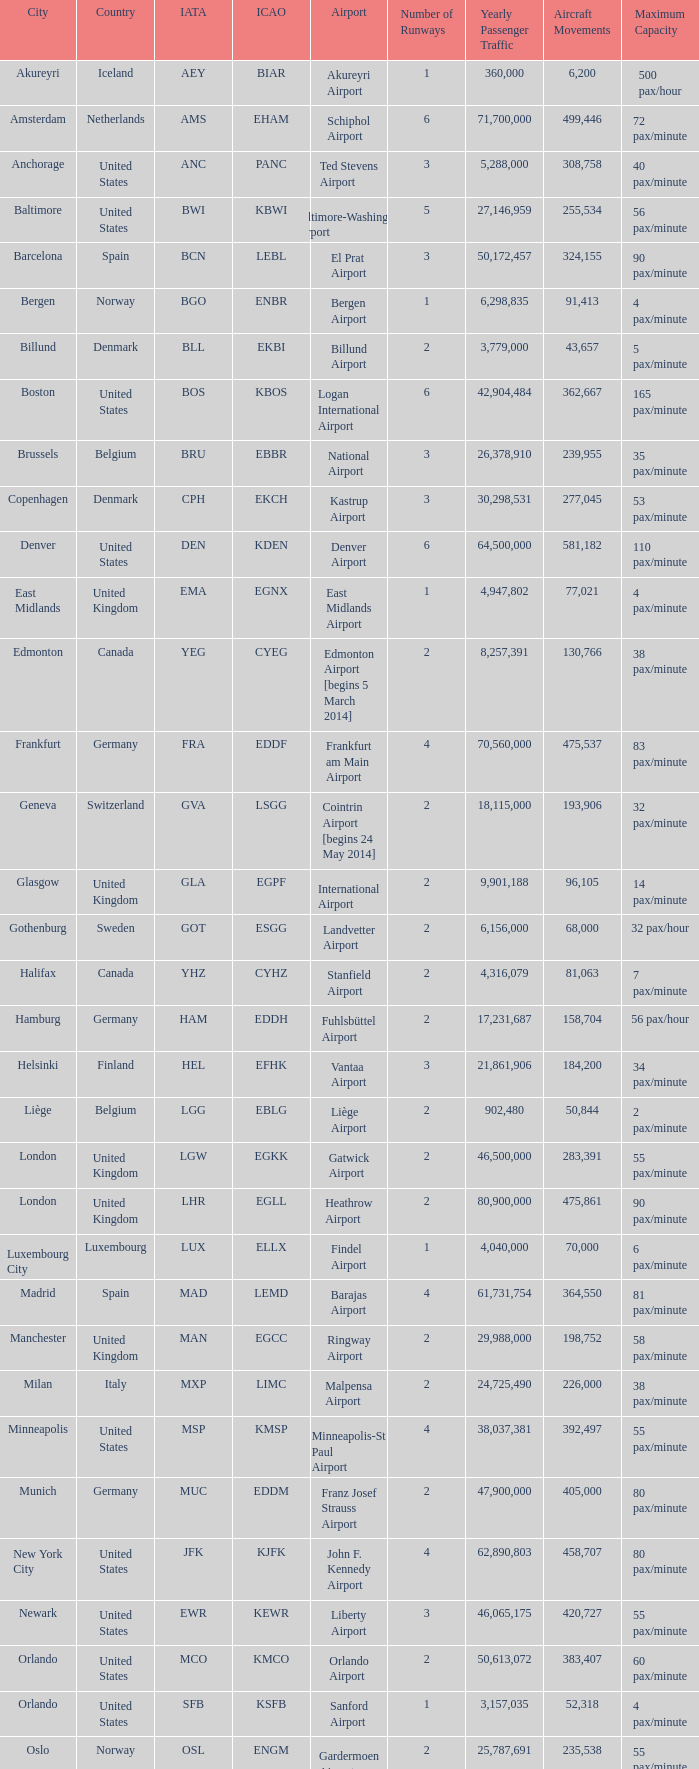Would you be able to parse every entry in this table? {'header': ['City', 'Country', 'IATA', 'ICAO', 'Airport', 'Number of Runways', 'Yearly Passenger Traffic', 'Aircraft Movements', 'Maximum Capacity'], 'rows': [['Akureyri', 'Iceland', 'AEY', 'BIAR', 'Akureyri Airport', '1', '360,000', '6,200', '500 pax/hour'], ['Amsterdam', 'Netherlands', 'AMS', 'EHAM', 'Schiphol Airport', '6', '71,700,000', '499,446', '72 pax/minute'], ['Anchorage', 'United States', 'ANC', 'PANC', 'Ted Stevens Airport', '3', '5,288,000', '308,758', '40 pax/minute'], ['Baltimore', 'United States', 'BWI', 'KBWI', 'Baltimore-Washington Airport', '5', '27,146,959', '255,534', '56 pax/minute'], ['Barcelona', 'Spain', 'BCN', 'LEBL', 'El Prat Airport', '3', '50,172,457', '324,155', '90 pax/minute'], ['Bergen', 'Norway', 'BGO', 'ENBR', 'Bergen Airport', '1', '6,298,835', '91,413', '4 pax/minute'], ['Billund', 'Denmark', 'BLL', 'EKBI', 'Billund Airport', '2', '3,779,000', '43,657', '5 pax/minute'], ['Boston', 'United States', 'BOS', 'KBOS', 'Logan International Airport', '6', '42,904,484', '362,667', '165 pax/minute'], ['Brussels', 'Belgium', 'BRU', 'EBBR', 'National Airport', '3', '26,378,910', '239,955', '35 pax/minute'], ['Copenhagen', 'Denmark', 'CPH', 'EKCH', 'Kastrup Airport', '3', '30,298,531', '277,045', '53 pax/minute'], ['Denver', 'United States', 'DEN', 'KDEN', 'Denver Airport', '6', '64,500,000', '581,182', '110 pax/minute'], ['East Midlands', 'United Kingdom', 'EMA', 'EGNX', 'East Midlands Airport', '1', '4,947,802', '77,021', '4 pax/minute'], ['Edmonton', 'Canada', 'YEG', 'CYEG', 'Edmonton Airport [begins 5 March 2014]', '2', '8,257,391', '130,766', '38 pax/minute'], ['Frankfurt', 'Germany', 'FRA', 'EDDF', 'Frankfurt am Main Airport', '4', '70,560,000', '475,537', '83 pax/minute'], ['Geneva', 'Switzerland', 'GVA', 'LSGG', 'Cointrin Airport [begins 24 May 2014]', '2', '18,115,000', '193,906', '32 pax/minute'], ['Glasgow', 'United Kingdom', 'GLA', 'EGPF', 'International Airport', '2', '9,901,188', '96,105', '14 pax/minute'], ['Gothenburg', 'Sweden', 'GOT', 'ESGG', 'Landvetter Airport', '2', '6,156,000', '68,000', '32 pax/hour'], ['Halifax', 'Canada', 'YHZ', 'CYHZ', 'Stanfield Airport', '2', '4,316,079', '81,063', '7 pax/minute'], ['Hamburg', 'Germany', 'HAM', 'EDDH', 'Fuhlsbüttel Airport', '2', '17,231,687', '158,704', '56 pax/hour'], ['Helsinki', 'Finland', 'HEL', 'EFHK', 'Vantaa Airport', '3', '21,861,906', '184,200', '34 pax/minute'], ['Liège', 'Belgium', 'LGG', 'EBLG', 'Liège Airport', '2', '902,480', '50,844', '2 pax/minute'], ['London', 'United Kingdom', 'LGW', 'EGKK', 'Gatwick Airport', '2', '46,500,000', '283,391', '55 pax/minute'], ['London', 'United Kingdom', 'LHR', 'EGLL', 'Heathrow Airport', '2', '80,900,000', '475,861', '90 pax/minute'], ['Luxembourg City', 'Luxembourg', 'LUX', 'ELLX', 'Findel Airport', '1', '4,040,000', '70,000', '6 pax/minute'], ['Madrid', 'Spain', 'MAD', 'LEMD', 'Barajas Airport', '4', '61,731,754', '364,550', '81 pax/minute'], ['Manchester', 'United Kingdom', 'MAN', 'EGCC', 'Ringway Airport', '2', '29,988,000', '198,752', '58 pax/minute'], ['Milan', 'Italy', 'MXP', 'LIMC', 'Malpensa Airport', '2', '24,725,490', '226,000', '38 pax/minute'], ['Minneapolis', 'United States', 'MSP', 'KMSP', 'Minneapolis-St Paul Airport', '4', '38,037,381', '392,497', '55 pax/minute'], ['Munich', 'Germany', 'MUC', 'EDDM', 'Franz Josef Strauss Airport', '2', '47,900,000', '405,000', '80 pax/minute'], ['New York City', 'United States', 'JFK', 'KJFK', 'John F. Kennedy Airport', '4', '62,890,803', '458,707', '80 pax/minute'], ['Newark', 'United States', 'EWR', 'KEWR', 'Liberty Airport', '3', '46,065,175', '420,727', '55 pax/minute'], ['Orlando', 'United States', 'MCO', 'KMCO', 'Orlando Airport', '2', '50,613,072', '383,407', '60 pax/minute'], ['Orlando', 'United States', 'SFB', 'KSFB', 'Sanford Airport', '1', '3,157,035', '52,318', '4 pax/minute'], ['Oslo', 'Norway', 'OSL', 'ENGM', 'Gardermoen Airport', '2', '25,787,691', '235,538', '55 pax/minute'], ['Paris', 'France', 'CDG', 'LFPG', 'Charles de Gaulle Airport', '4', '72,229,723', '475,654', '95 pax/minute'], ['Reykjavík', 'Iceland', 'KEF', 'BIKF', 'Keflavik Airport', '1', '8,755,000', '84,200', '8 pax/minute'], ['Saint Petersburg', 'Russia', 'LED', 'ULLI', 'Pulkovo Airport', '3', '19,951,000', '166,000', '24 pax/minute'], ['San Francisco', 'United States', 'SFO', 'KSFO', 'San Francisco Airport', '4', '57,793,313', '470,755', '80 pax/minute'], ['Seattle', 'United States', 'SEA', 'KSEA', 'Seattle–Tacoma Airport', '3', '49,849,520', '425,800', '70 pax/minute'], ['Stavanger', 'Norway', 'SVG', 'ENZV', 'Sola Airport', '1', '4,664,919', '65,571', '10 pax/hour'], ['Stockholm', 'Sweden', 'ARN', 'ESSA', 'Arlanda Airport', '4', '25,946,000', '216,000', '35 pax/minute'], ['Toronto', 'Canada', 'YYZ', 'CYYZ', 'Pearson Airport', '5', '49,507,418', '468,480', '135 pax/minute'], ['Trondheim', 'Norway', 'TRD', 'ENVA', 'Trondheim Airport', '1', '4,880,000', '69,091', '5 pax/minute'], ['Vancouver', 'Canada', 'YVR', 'CYVR', 'Vancouver Airport [begins 13 May 2014]', '3', '25,936,000', '332,277', '60 pax/minute'], ['Washington, D.C.', 'United States', 'IAD', 'KIAD', 'Dulles Airport', '2', '24,097,044', '215,399', '60 pax/minute'], ['Zurich', 'Switzerland', 'ZRH', 'LSZH', 'Kloten Airport', '3', '31,150,000', '267,504', '66 pax/minute']]} What Airport's IATA is SEA? Seattle–Tacoma Airport. 